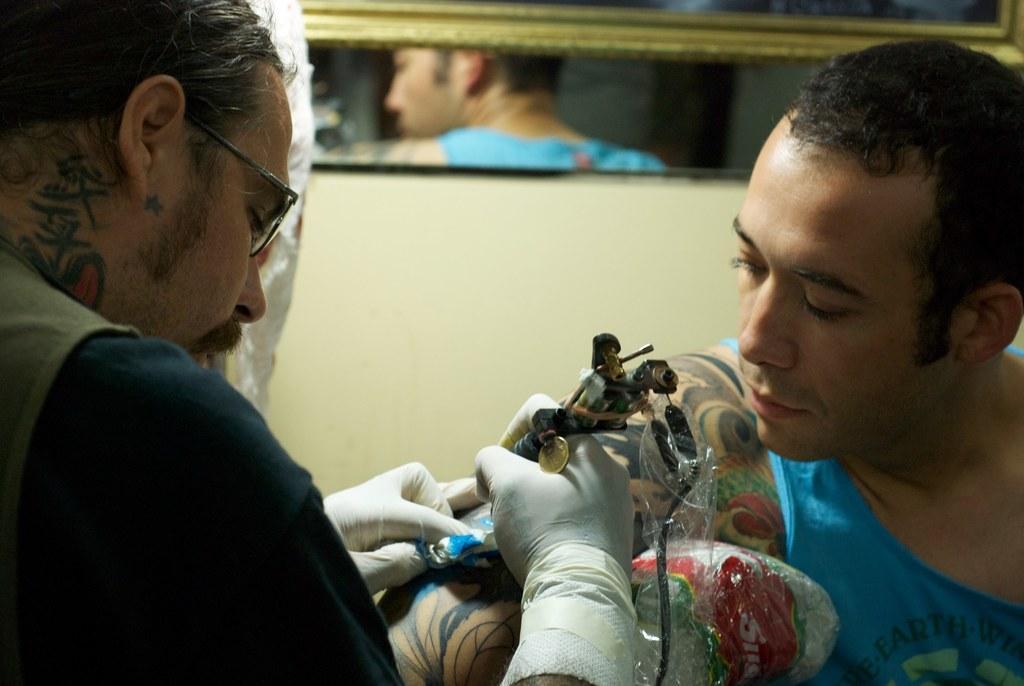Please provide a concise description of this image. In this picture I can see there are two persons sitting here and this person is holding a tattoo machine in his hand and this person is looking at the hand. In the backdrop I can see there is a wall and there is a mirror on the wall. 